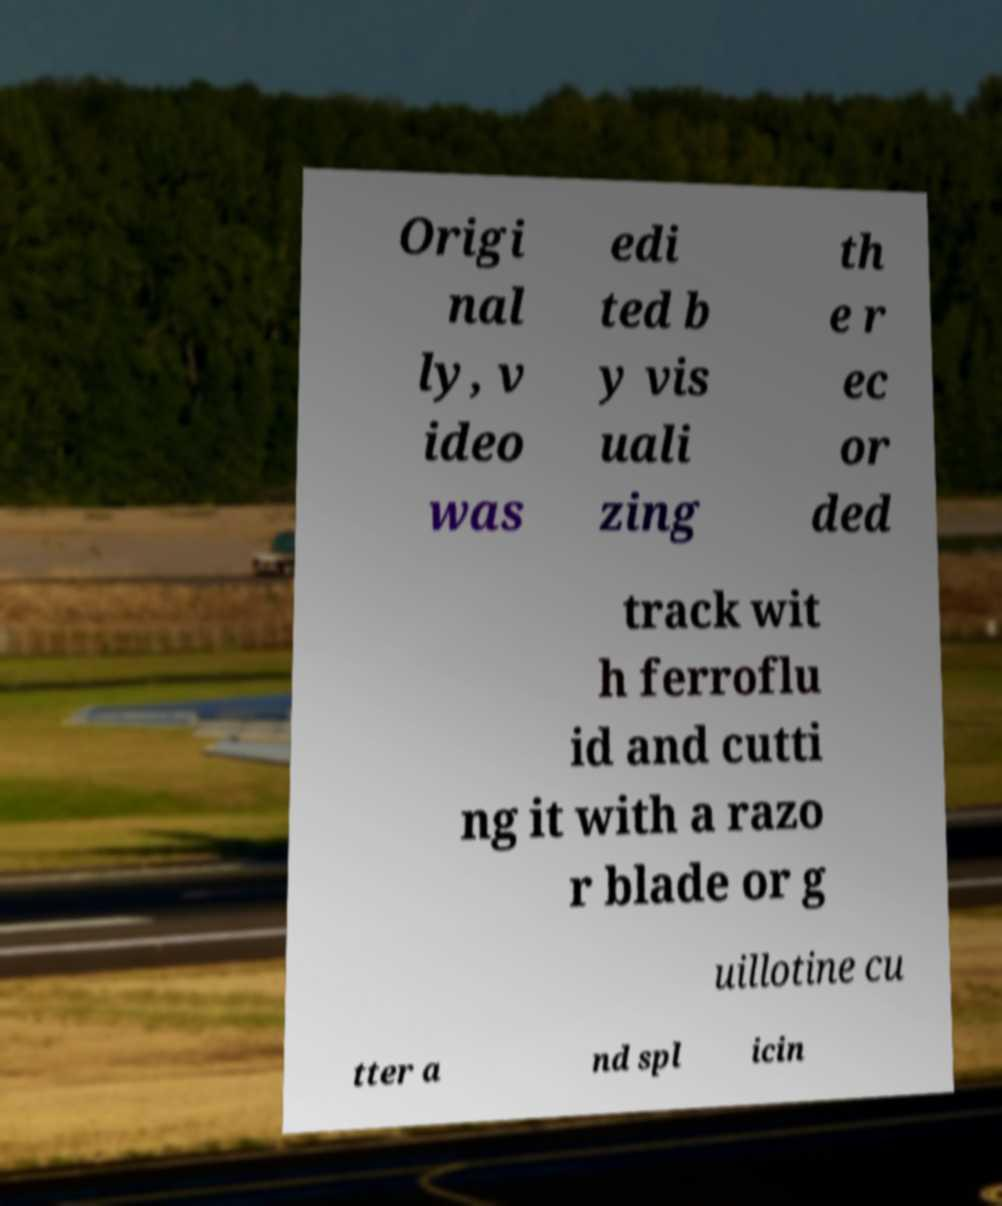Please identify and transcribe the text found in this image. Origi nal ly, v ideo was edi ted b y vis uali zing th e r ec or ded track wit h ferroflu id and cutti ng it with a razo r blade or g uillotine cu tter a nd spl icin 